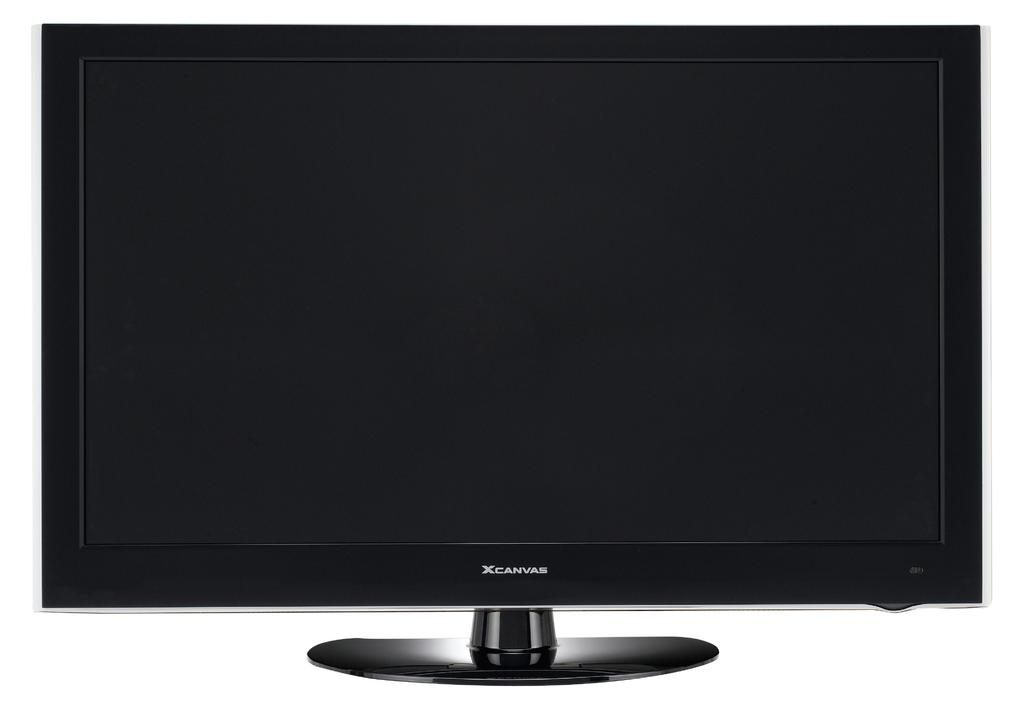<image>
Render a clear and concise summary of the photo. A black XCanvas computer monitor on a white background. 